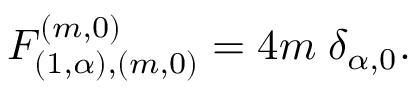Convert formula to latex. <formula><loc_0><loc_0><loc_500><loc_500>F _ { ( 1 , \alpha ) , ( m , 0 ) } ^ { ( m , 0 ) } = 4 m \, \delta _ { \alpha , 0 } .</formula> 